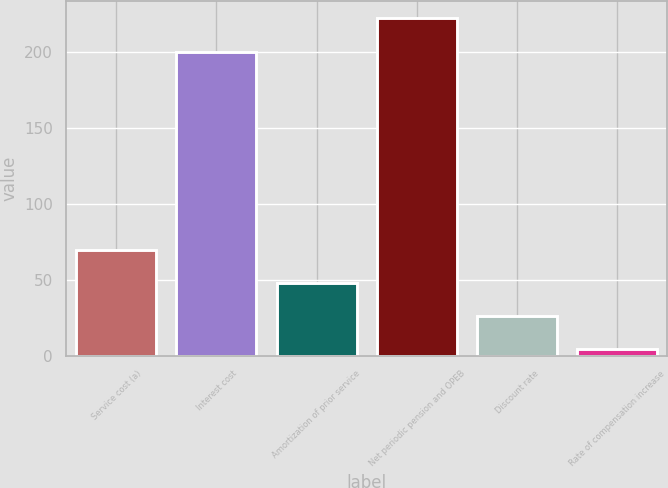Convert chart. <chart><loc_0><loc_0><loc_500><loc_500><bar_chart><fcel>Service cost (a)<fcel>Interest cost<fcel>Amortization of prior service<fcel>Net periodic pension and OPEB<fcel>Discount rate<fcel>Rate of compensation increase<nl><fcel>69.94<fcel>200<fcel>48.07<fcel>223<fcel>26.2<fcel>4.33<nl></chart> 